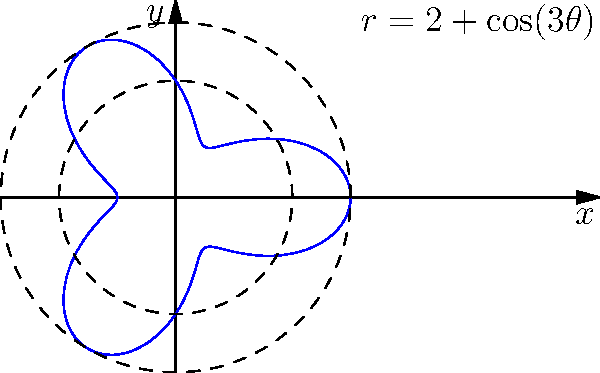You're planning a unique garden plot for your children's school. The plot's boundary is defined by the polar equation $r = 2 + \cos(3\theta)$ (measured in meters). Calculate the area of this garden plot to determine how much soil you'll need to purchase. Round your answer to the nearest square meter. To find the area of this garden plot, we'll use polar integration:

1) The formula for area in polar coordinates is:
   $$A = \frac{1}{2} \int_{0}^{2\pi} r^2(\theta) d\theta$$

2) Our function is $r(\theta) = 2 + \cos(3\theta)$, so we need to square this:
   $$r^2(\theta) = (2 + \cos(3\theta))^2 = 4 + 4\cos(3\theta) + \cos^2(3\theta)$$

3) Now, we set up our integral:
   $$A = \frac{1}{2} \int_{0}^{2\pi} (4 + 4\cos(3\theta) + \cos^2(3\theta)) d\theta$$

4) Let's integrate each term:
   - $\int_{0}^{2\pi} 4 d\theta = 4\theta |_{0}^{2\pi} = 8\pi$
   - $\int_{0}^{2\pi} 4\cos(3\theta) d\theta = \frac{4}{3}\sin(3\theta) |_{0}^{2\pi} = 0$
   - $\int_{0}^{2\pi} \cos^2(3\theta) d\theta = \frac{1}{2}\int_{0}^{2\pi} (1 + \cos(6\theta)) d\theta = \frac{1}{2}(\theta + \frac{1}{6}\sin(6\theta)) |_{0}^{2\pi} = \pi$

5) Adding these up and multiplying by $\frac{1}{2}$:
   $$A = \frac{1}{2}(8\pi + 0 + \pi) = \frac{9\pi}{2} \approx 14.14 \text{ m}^2$$

6) Rounding to the nearest square meter:
   $$A \approx 14 \text{ m}^2$$
Answer: 14 m² 